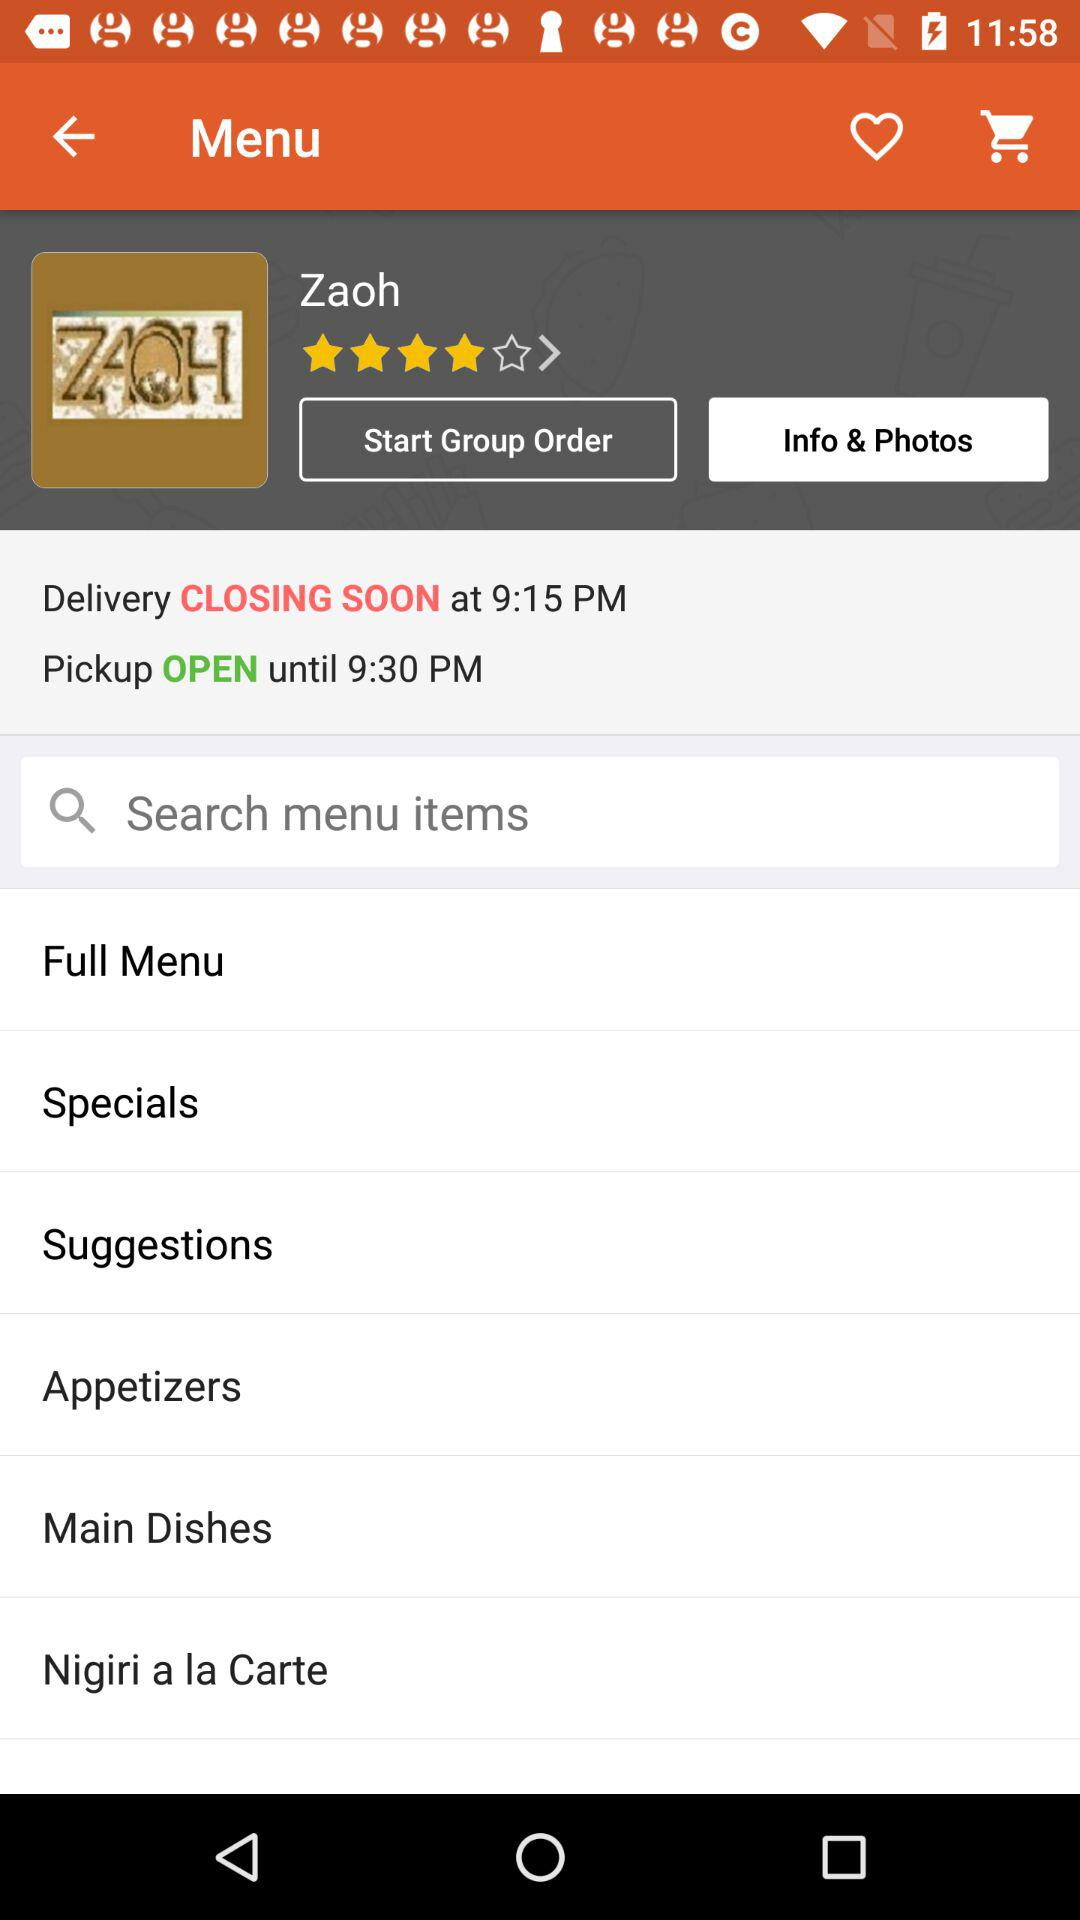What is "Pickup OPEN" timing? The Pickup opens until 9:30 PM. 